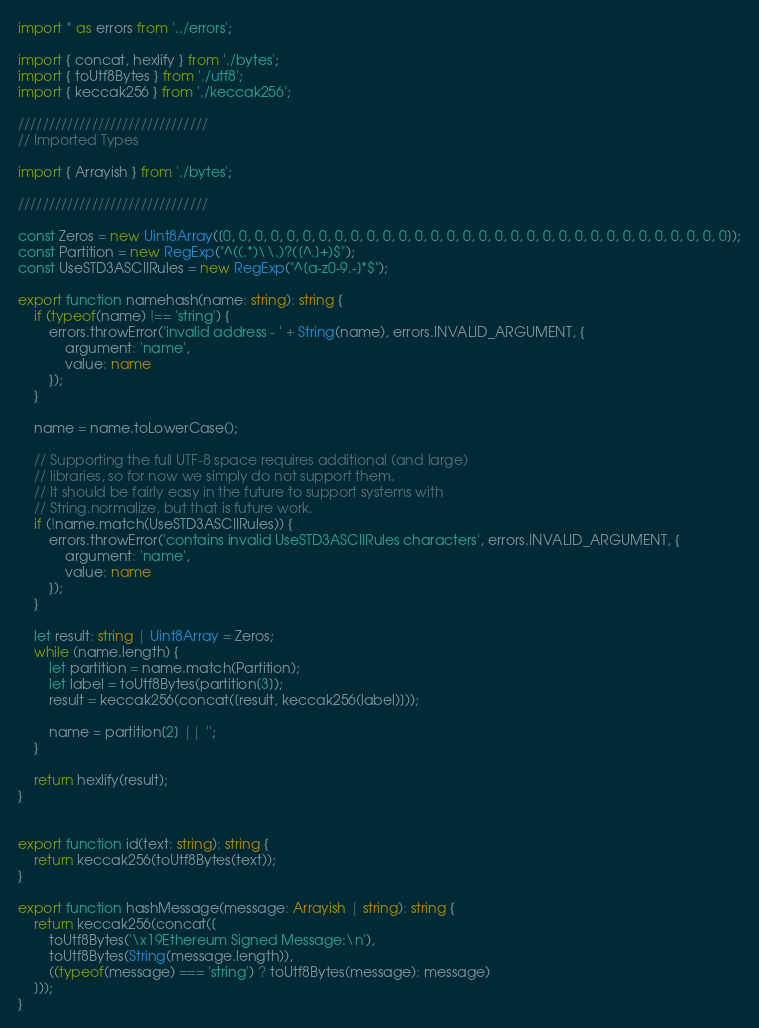<code> <loc_0><loc_0><loc_500><loc_500><_TypeScript_>import * as errors from '../errors';

import { concat, hexlify } from './bytes';
import { toUtf8Bytes } from './utf8';
import { keccak256 } from './keccak256';

///////////////////////////////
// Imported Types

import { Arrayish } from './bytes';

///////////////////////////////

const Zeros = new Uint8Array([0, 0, 0, 0, 0, 0, 0, 0, 0, 0, 0, 0, 0, 0, 0, 0, 0, 0, 0, 0, 0, 0, 0, 0, 0, 0, 0, 0, 0, 0, 0, 0]);
const Partition = new RegExp("^((.*)\\.)?([^.]+)$");
const UseSTD3ASCIIRules = new RegExp("^[a-z0-9.-]*$");

export function namehash(name: string): string {
    if (typeof(name) !== 'string') {
        errors.throwError('invalid address - ' + String(name), errors.INVALID_ARGUMENT, {
            argument: 'name',
            value: name
        });
    }

    name = name.toLowerCase();

    // Supporting the full UTF-8 space requires additional (and large)
    // libraries, so for now we simply do not support them.
    // It should be fairly easy in the future to support systems with
    // String.normalize, but that is future work.
    if (!name.match(UseSTD3ASCIIRules)) {
        errors.throwError('contains invalid UseSTD3ASCIIRules characters', errors.INVALID_ARGUMENT, {
            argument: 'name',
            value: name
        });
    }

    let result: string | Uint8Array = Zeros;
    while (name.length) {
        let partition = name.match(Partition);
        let label = toUtf8Bytes(partition[3]);
        result = keccak256(concat([result, keccak256(label)]));

        name = partition[2] || '';
    }

    return hexlify(result);
}


export function id(text: string): string {
    return keccak256(toUtf8Bytes(text));
}

export function hashMessage(message: Arrayish | string): string {
    return keccak256(concat([
        toUtf8Bytes('\x19Ethereum Signed Message:\n'),
        toUtf8Bytes(String(message.length)),
        ((typeof(message) === 'string') ? toUtf8Bytes(message): message)
    ]));
}

</code> 